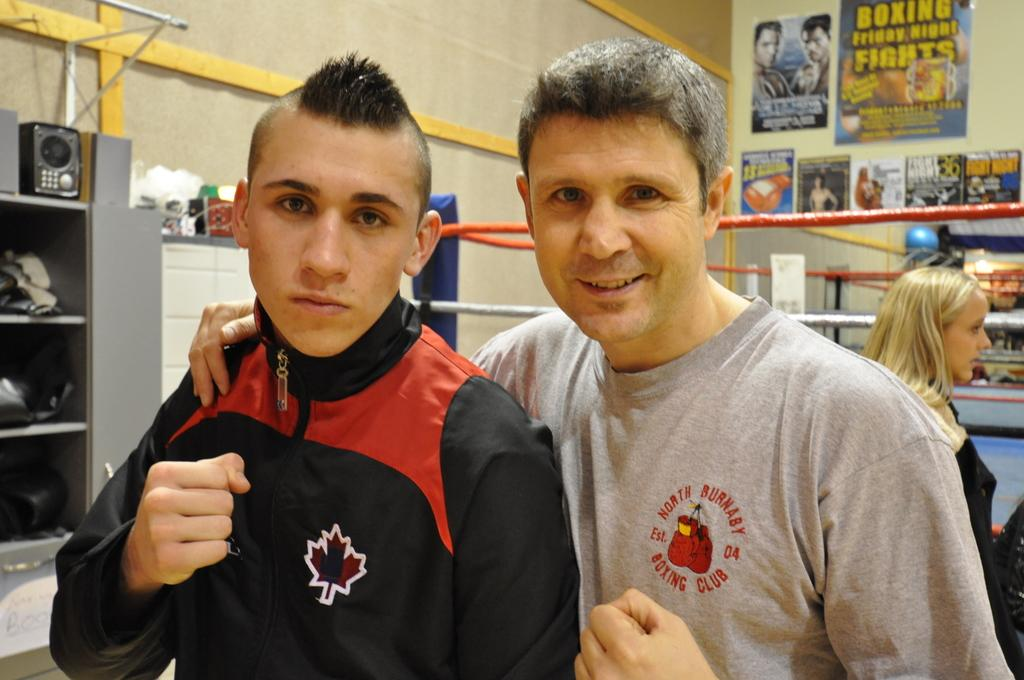<image>
Write a terse but informative summary of the picture. A man poses for a photo wearing a North Burnaby boxing club shirt. 